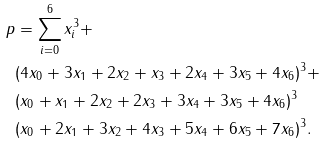Convert formula to latex. <formula><loc_0><loc_0><loc_500><loc_500>p & = \sum _ { i = 0 } ^ { 6 } x _ { i } ^ { 3 } + \\ & ( 4 x _ { 0 } + 3 x _ { 1 } + 2 x _ { 2 } + x _ { 3 } + 2 x _ { 4 } + 3 x _ { 5 } + 4 x _ { 6 } ) ^ { 3 } + \\ & ( x _ { 0 } + x _ { 1 } + 2 x _ { 2 } + 2 x _ { 3 } + 3 x _ { 4 } + 3 x _ { 5 } + 4 x _ { 6 } ) ^ { 3 } \\ & ( x _ { 0 } + 2 x _ { 1 } + 3 x _ { 2 } + 4 x _ { 3 } + 5 x _ { 4 } + 6 x _ { 5 } + 7 x _ { 6 } ) ^ { 3 } .</formula> 